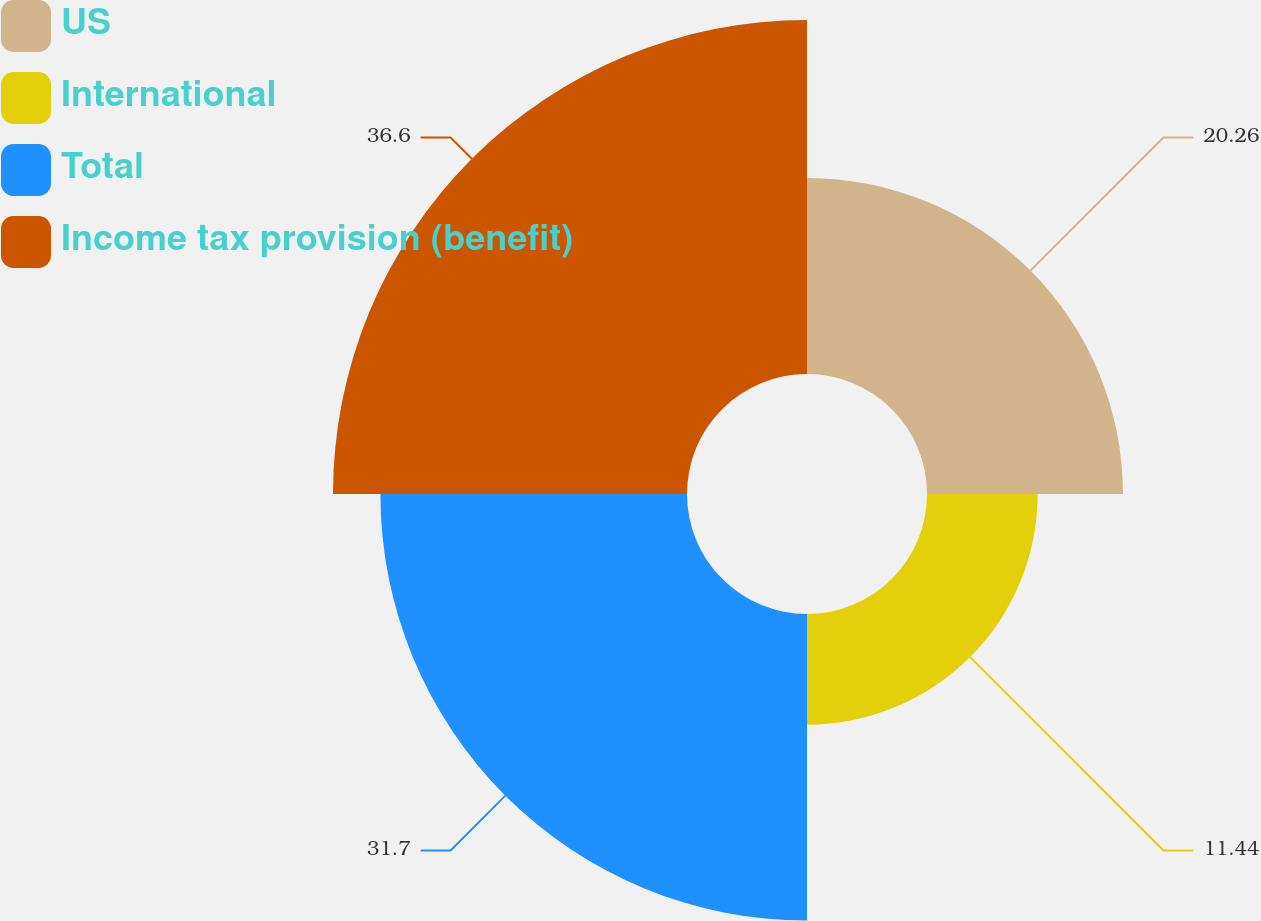<chart> <loc_0><loc_0><loc_500><loc_500><pie_chart><fcel>US<fcel>International<fcel>Total<fcel>Income tax provision (benefit)<nl><fcel>20.26%<fcel>11.44%<fcel>31.7%<fcel>36.6%<nl></chart> 